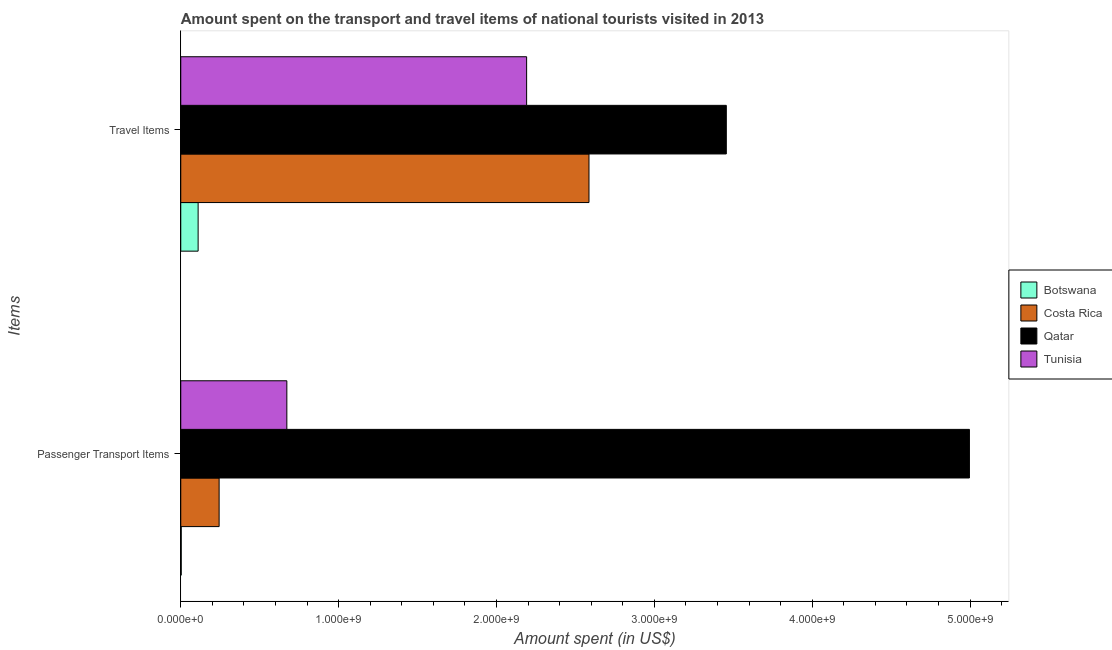How many different coloured bars are there?
Give a very brief answer. 4. Are the number of bars per tick equal to the number of legend labels?
Your answer should be compact. Yes. What is the label of the 1st group of bars from the top?
Offer a terse response. Travel Items. What is the amount spent in travel items in Tunisia?
Ensure brevity in your answer.  2.19e+09. Across all countries, what is the maximum amount spent in travel items?
Your answer should be compact. 3.46e+09. Across all countries, what is the minimum amount spent in travel items?
Keep it short and to the point. 1.10e+08. In which country was the amount spent on passenger transport items maximum?
Keep it short and to the point. Qatar. In which country was the amount spent on passenger transport items minimum?
Offer a very short reply. Botswana. What is the total amount spent in travel items in the graph?
Offer a terse response. 8.34e+09. What is the difference between the amount spent in travel items in Tunisia and that in Qatar?
Make the answer very short. -1.26e+09. What is the difference between the amount spent in travel items in Costa Rica and the amount spent on passenger transport items in Qatar?
Your answer should be compact. -2.41e+09. What is the average amount spent on passenger transport items per country?
Make the answer very short. 1.48e+09. What is the difference between the amount spent on passenger transport items and amount spent in travel items in Qatar?
Your response must be concise. 1.54e+09. In how many countries, is the amount spent on passenger transport items greater than 4800000000 US$?
Keep it short and to the point. 1. What is the ratio of the amount spent on passenger transport items in Botswana to that in Tunisia?
Make the answer very short. 0. In how many countries, is the amount spent on passenger transport items greater than the average amount spent on passenger transport items taken over all countries?
Your answer should be very brief. 1. What does the 1st bar from the top in Travel Items represents?
Provide a short and direct response. Tunisia. What does the 3rd bar from the bottom in Passenger Transport Items represents?
Ensure brevity in your answer.  Qatar. How many bars are there?
Make the answer very short. 8. Are all the bars in the graph horizontal?
Ensure brevity in your answer.  Yes. How many countries are there in the graph?
Your answer should be compact. 4. Are the values on the major ticks of X-axis written in scientific E-notation?
Provide a succinct answer. Yes. Does the graph contain any zero values?
Your response must be concise. No. Does the graph contain grids?
Ensure brevity in your answer.  No. How many legend labels are there?
Your response must be concise. 4. What is the title of the graph?
Your response must be concise. Amount spent on the transport and travel items of national tourists visited in 2013. Does "Upper middle income" appear as one of the legend labels in the graph?
Keep it short and to the point. No. What is the label or title of the X-axis?
Provide a short and direct response. Amount spent (in US$). What is the label or title of the Y-axis?
Offer a terse response. Items. What is the Amount spent (in US$) of Costa Rica in Passenger Transport Items?
Offer a very short reply. 2.43e+08. What is the Amount spent (in US$) of Qatar in Passenger Transport Items?
Your answer should be compact. 5.00e+09. What is the Amount spent (in US$) in Tunisia in Passenger Transport Items?
Offer a very short reply. 6.72e+08. What is the Amount spent (in US$) of Botswana in Travel Items?
Offer a very short reply. 1.10e+08. What is the Amount spent (in US$) of Costa Rica in Travel Items?
Make the answer very short. 2.59e+09. What is the Amount spent (in US$) of Qatar in Travel Items?
Offer a terse response. 3.46e+09. What is the Amount spent (in US$) in Tunisia in Travel Items?
Offer a very short reply. 2.19e+09. Across all Items, what is the maximum Amount spent (in US$) in Botswana?
Offer a very short reply. 1.10e+08. Across all Items, what is the maximum Amount spent (in US$) of Costa Rica?
Offer a terse response. 2.59e+09. Across all Items, what is the maximum Amount spent (in US$) of Qatar?
Keep it short and to the point. 5.00e+09. Across all Items, what is the maximum Amount spent (in US$) in Tunisia?
Your response must be concise. 2.19e+09. Across all Items, what is the minimum Amount spent (in US$) of Costa Rica?
Ensure brevity in your answer.  2.43e+08. Across all Items, what is the minimum Amount spent (in US$) in Qatar?
Provide a succinct answer. 3.46e+09. Across all Items, what is the minimum Amount spent (in US$) in Tunisia?
Provide a succinct answer. 6.72e+08. What is the total Amount spent (in US$) in Botswana in the graph?
Ensure brevity in your answer.  1.13e+08. What is the total Amount spent (in US$) of Costa Rica in the graph?
Give a very brief answer. 2.83e+09. What is the total Amount spent (in US$) in Qatar in the graph?
Offer a terse response. 8.45e+09. What is the total Amount spent (in US$) in Tunisia in the graph?
Offer a terse response. 2.86e+09. What is the difference between the Amount spent (in US$) in Botswana in Passenger Transport Items and that in Travel Items?
Give a very brief answer. -1.07e+08. What is the difference between the Amount spent (in US$) of Costa Rica in Passenger Transport Items and that in Travel Items?
Make the answer very short. -2.34e+09. What is the difference between the Amount spent (in US$) of Qatar in Passenger Transport Items and that in Travel Items?
Your response must be concise. 1.54e+09. What is the difference between the Amount spent (in US$) in Tunisia in Passenger Transport Items and that in Travel Items?
Keep it short and to the point. -1.52e+09. What is the difference between the Amount spent (in US$) of Botswana in Passenger Transport Items and the Amount spent (in US$) of Costa Rica in Travel Items?
Provide a short and direct response. -2.58e+09. What is the difference between the Amount spent (in US$) in Botswana in Passenger Transport Items and the Amount spent (in US$) in Qatar in Travel Items?
Ensure brevity in your answer.  -3.45e+09. What is the difference between the Amount spent (in US$) in Botswana in Passenger Transport Items and the Amount spent (in US$) in Tunisia in Travel Items?
Your answer should be compact. -2.19e+09. What is the difference between the Amount spent (in US$) of Costa Rica in Passenger Transport Items and the Amount spent (in US$) of Qatar in Travel Items?
Give a very brief answer. -3.21e+09. What is the difference between the Amount spent (in US$) in Costa Rica in Passenger Transport Items and the Amount spent (in US$) in Tunisia in Travel Items?
Your response must be concise. -1.95e+09. What is the difference between the Amount spent (in US$) of Qatar in Passenger Transport Items and the Amount spent (in US$) of Tunisia in Travel Items?
Keep it short and to the point. 2.80e+09. What is the average Amount spent (in US$) of Botswana per Items?
Offer a very short reply. 5.65e+07. What is the average Amount spent (in US$) of Costa Rica per Items?
Offer a terse response. 1.41e+09. What is the average Amount spent (in US$) in Qatar per Items?
Keep it short and to the point. 4.23e+09. What is the average Amount spent (in US$) in Tunisia per Items?
Keep it short and to the point. 1.43e+09. What is the difference between the Amount spent (in US$) in Botswana and Amount spent (in US$) in Costa Rica in Passenger Transport Items?
Offer a very short reply. -2.40e+08. What is the difference between the Amount spent (in US$) in Botswana and Amount spent (in US$) in Qatar in Passenger Transport Items?
Provide a succinct answer. -4.99e+09. What is the difference between the Amount spent (in US$) in Botswana and Amount spent (in US$) in Tunisia in Passenger Transport Items?
Provide a short and direct response. -6.69e+08. What is the difference between the Amount spent (in US$) of Costa Rica and Amount spent (in US$) of Qatar in Passenger Transport Items?
Your response must be concise. -4.75e+09. What is the difference between the Amount spent (in US$) in Costa Rica and Amount spent (in US$) in Tunisia in Passenger Transport Items?
Make the answer very short. -4.29e+08. What is the difference between the Amount spent (in US$) in Qatar and Amount spent (in US$) in Tunisia in Passenger Transport Items?
Give a very brief answer. 4.32e+09. What is the difference between the Amount spent (in US$) in Botswana and Amount spent (in US$) in Costa Rica in Travel Items?
Your answer should be very brief. -2.48e+09. What is the difference between the Amount spent (in US$) of Botswana and Amount spent (in US$) of Qatar in Travel Items?
Your answer should be compact. -3.35e+09. What is the difference between the Amount spent (in US$) of Botswana and Amount spent (in US$) of Tunisia in Travel Items?
Keep it short and to the point. -2.08e+09. What is the difference between the Amount spent (in US$) of Costa Rica and Amount spent (in US$) of Qatar in Travel Items?
Provide a succinct answer. -8.70e+08. What is the difference between the Amount spent (in US$) of Costa Rica and Amount spent (in US$) of Tunisia in Travel Items?
Provide a succinct answer. 3.95e+08. What is the difference between the Amount spent (in US$) in Qatar and Amount spent (in US$) in Tunisia in Travel Items?
Make the answer very short. 1.26e+09. What is the ratio of the Amount spent (in US$) in Botswana in Passenger Transport Items to that in Travel Items?
Keep it short and to the point. 0.03. What is the ratio of the Amount spent (in US$) in Costa Rica in Passenger Transport Items to that in Travel Items?
Your response must be concise. 0.09. What is the ratio of the Amount spent (in US$) in Qatar in Passenger Transport Items to that in Travel Items?
Your answer should be compact. 1.45. What is the ratio of the Amount spent (in US$) in Tunisia in Passenger Transport Items to that in Travel Items?
Your answer should be very brief. 0.31. What is the difference between the highest and the second highest Amount spent (in US$) of Botswana?
Provide a succinct answer. 1.07e+08. What is the difference between the highest and the second highest Amount spent (in US$) of Costa Rica?
Offer a terse response. 2.34e+09. What is the difference between the highest and the second highest Amount spent (in US$) in Qatar?
Offer a very short reply. 1.54e+09. What is the difference between the highest and the second highest Amount spent (in US$) of Tunisia?
Your response must be concise. 1.52e+09. What is the difference between the highest and the lowest Amount spent (in US$) of Botswana?
Your answer should be compact. 1.07e+08. What is the difference between the highest and the lowest Amount spent (in US$) in Costa Rica?
Your answer should be very brief. 2.34e+09. What is the difference between the highest and the lowest Amount spent (in US$) of Qatar?
Your response must be concise. 1.54e+09. What is the difference between the highest and the lowest Amount spent (in US$) in Tunisia?
Provide a succinct answer. 1.52e+09. 